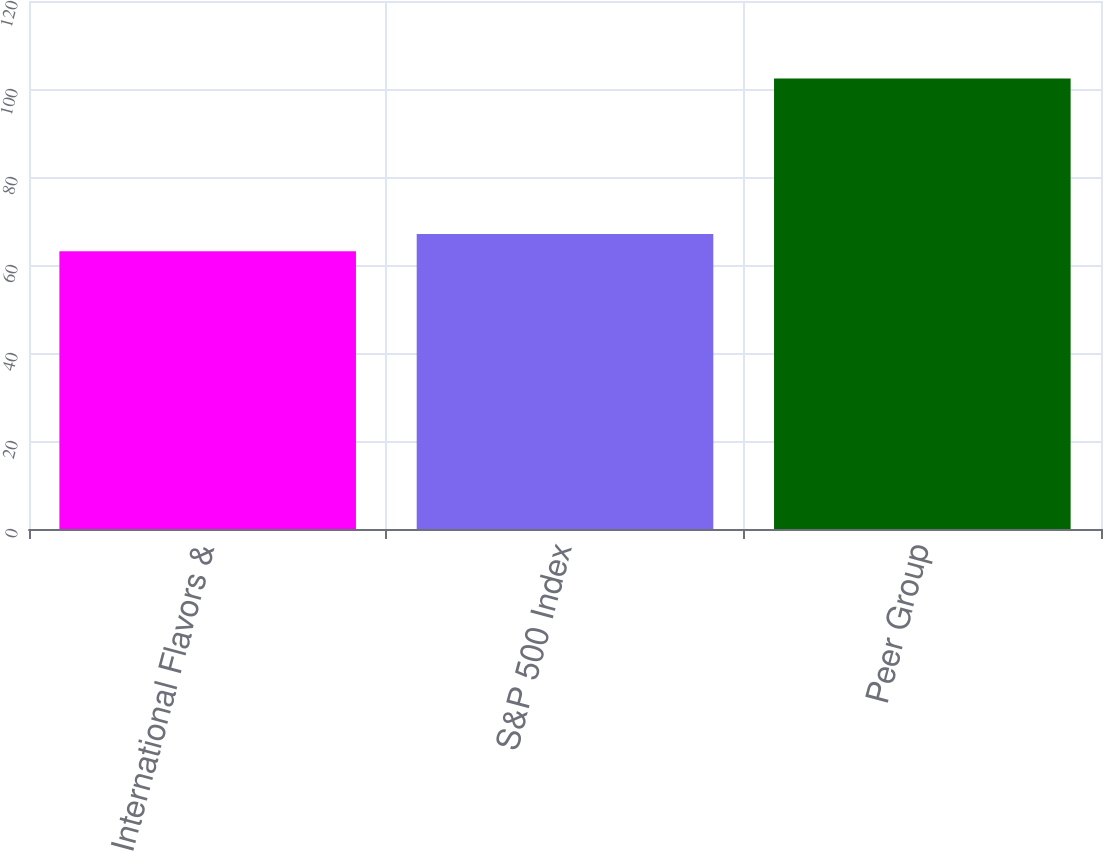<chart> <loc_0><loc_0><loc_500><loc_500><bar_chart><fcel>International Flavors &<fcel>S&P 500 Index<fcel>Peer Group<nl><fcel>63.13<fcel>67.06<fcel>102.4<nl></chart> 